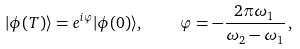Convert formula to latex. <formula><loc_0><loc_0><loc_500><loc_500>| \phi ( T ) \rangle = e ^ { i { \varphi } } | \phi ( 0 ) \rangle , \quad { \varphi } = - \frac { 2 \pi \omega _ { 1 } } { \omega _ { 2 } - \omega _ { 1 } } \, ,</formula> 